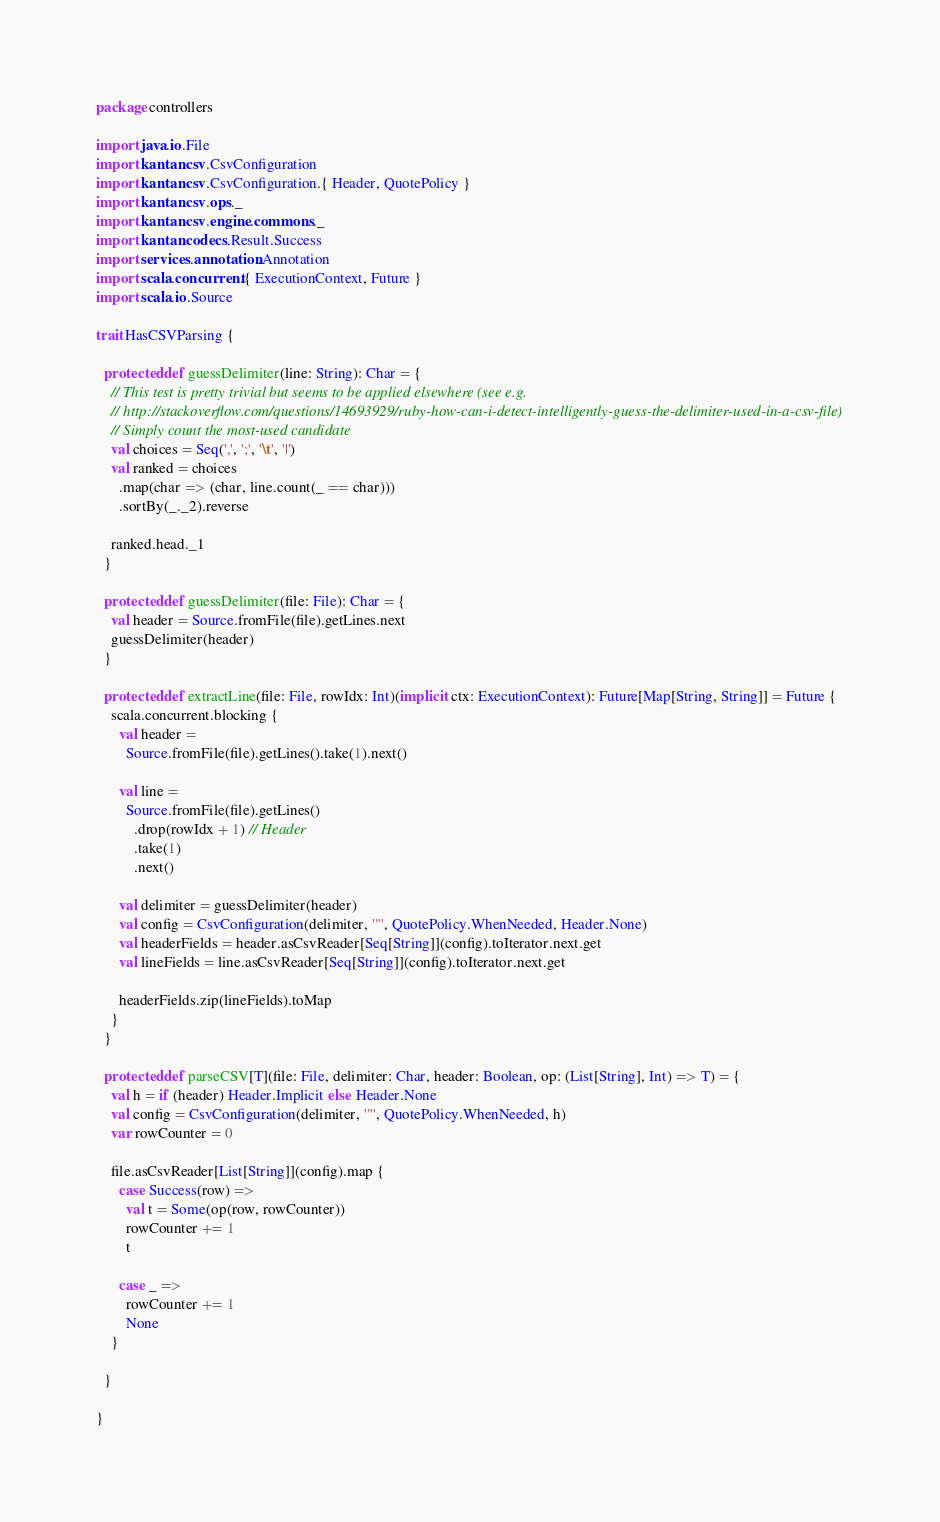Convert code to text. <code><loc_0><loc_0><loc_500><loc_500><_Scala_>package controllers

import java.io.File
import kantan.csv.CsvConfiguration
import kantan.csv.CsvConfiguration.{ Header, QuotePolicy }
import kantan.csv.ops._
import kantan.csv.engine.commons._
import kantan.codecs.Result.Success
import services.annotation.Annotation
import scala.concurrent.{ ExecutionContext, Future }
import scala.io.Source

trait HasCSVParsing {
  
  protected def guessDelimiter(line: String): Char = {
    // This test is pretty trivial but seems to be applied elsewhere (see e.g.
    // http://stackoverflow.com/questions/14693929/ruby-how-can-i-detect-intelligently-guess-the-delimiter-used-in-a-csv-file)
    // Simply count the most-used candidate
    val choices = Seq(',', ';', '\t', '|')
    val ranked = choices
      .map(char => (char, line.count(_ == char)))
      .sortBy(_._2).reverse
      
    ranked.head._1
  }
  
  protected def guessDelimiter(file: File): Char = {
    val header = Source.fromFile(file).getLines.next
    guessDelimiter(header)     
  }
  
  protected def extractLine(file: File, rowIdx: Int)(implicit ctx: ExecutionContext): Future[Map[String, String]] = Future {
    scala.concurrent.blocking {
      val header = 
        Source.fromFile(file).getLines().take(1).next()
        
      val line = 
        Source.fromFile(file).getLines()
          .drop(rowIdx + 1) // Header
          .take(1)
          .next()
          
      val delimiter = guessDelimiter(header)
      val config = CsvConfiguration(delimiter, '"', QuotePolicy.WhenNeeded, Header.None)
      val headerFields = header.asCsvReader[Seq[String]](config).toIterator.next.get
      val lineFields = line.asCsvReader[Seq[String]](config).toIterator.next.get
      
      headerFields.zip(lineFields).toMap
    }
  }
  
  protected def parseCSV[T](file: File, delimiter: Char, header: Boolean, op: (List[String], Int) => T) = {
    val h = if (header) Header.Implicit else Header.None
    val config = CsvConfiguration(delimiter, '"', QuotePolicy.WhenNeeded, h)
    var rowCounter = 0
    
    file.asCsvReader[List[String]](config).map {
      case Success(row) =>
        val t = Some(op(row, rowCounter))
        rowCounter += 1
        t
        
      case _ => 
        rowCounter += 1
        None
    }
    
  }
  
}</code> 